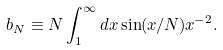<formula> <loc_0><loc_0><loc_500><loc_500>b _ { N } \equiv N \int ^ { \infty } _ { 1 } d x \sin ( x / N ) x ^ { - 2 } .</formula> 